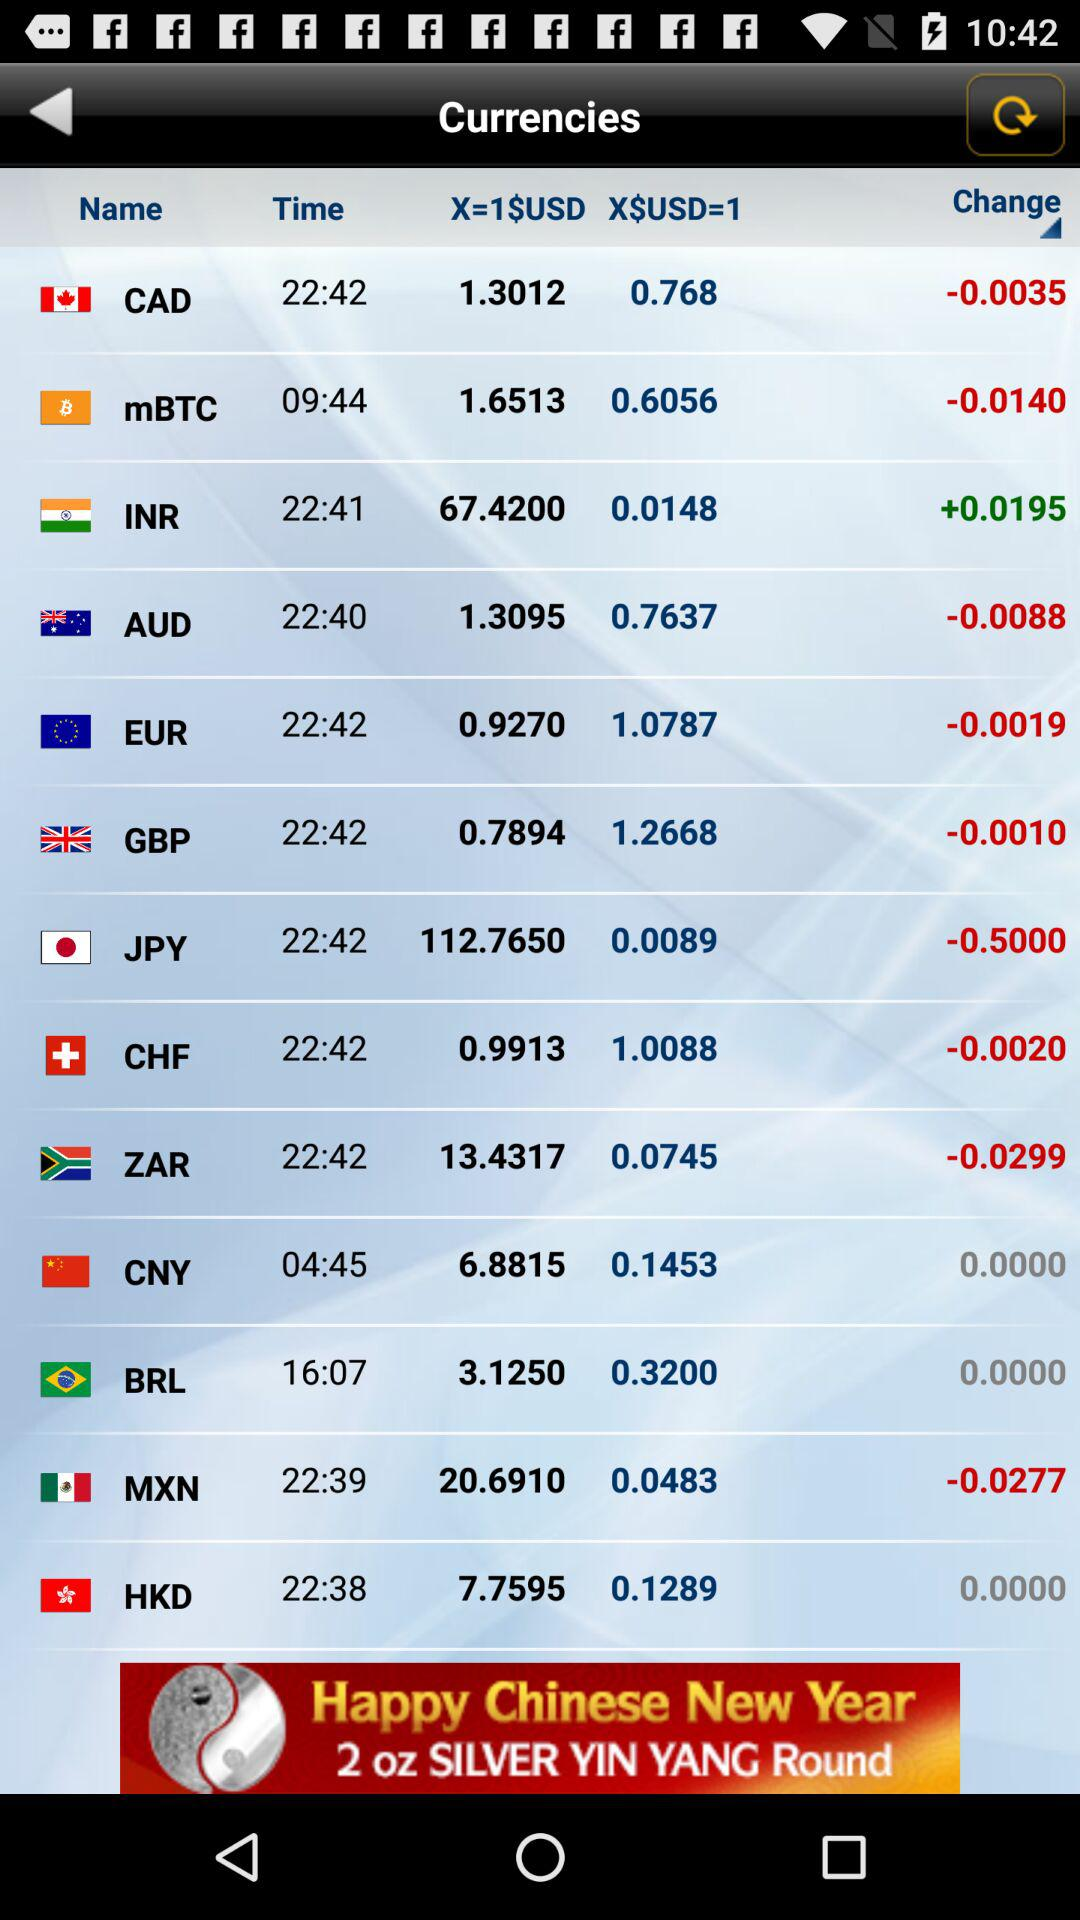What is the value of 1 USD in INR? The value of 1 USD is 67.4200 INR. 